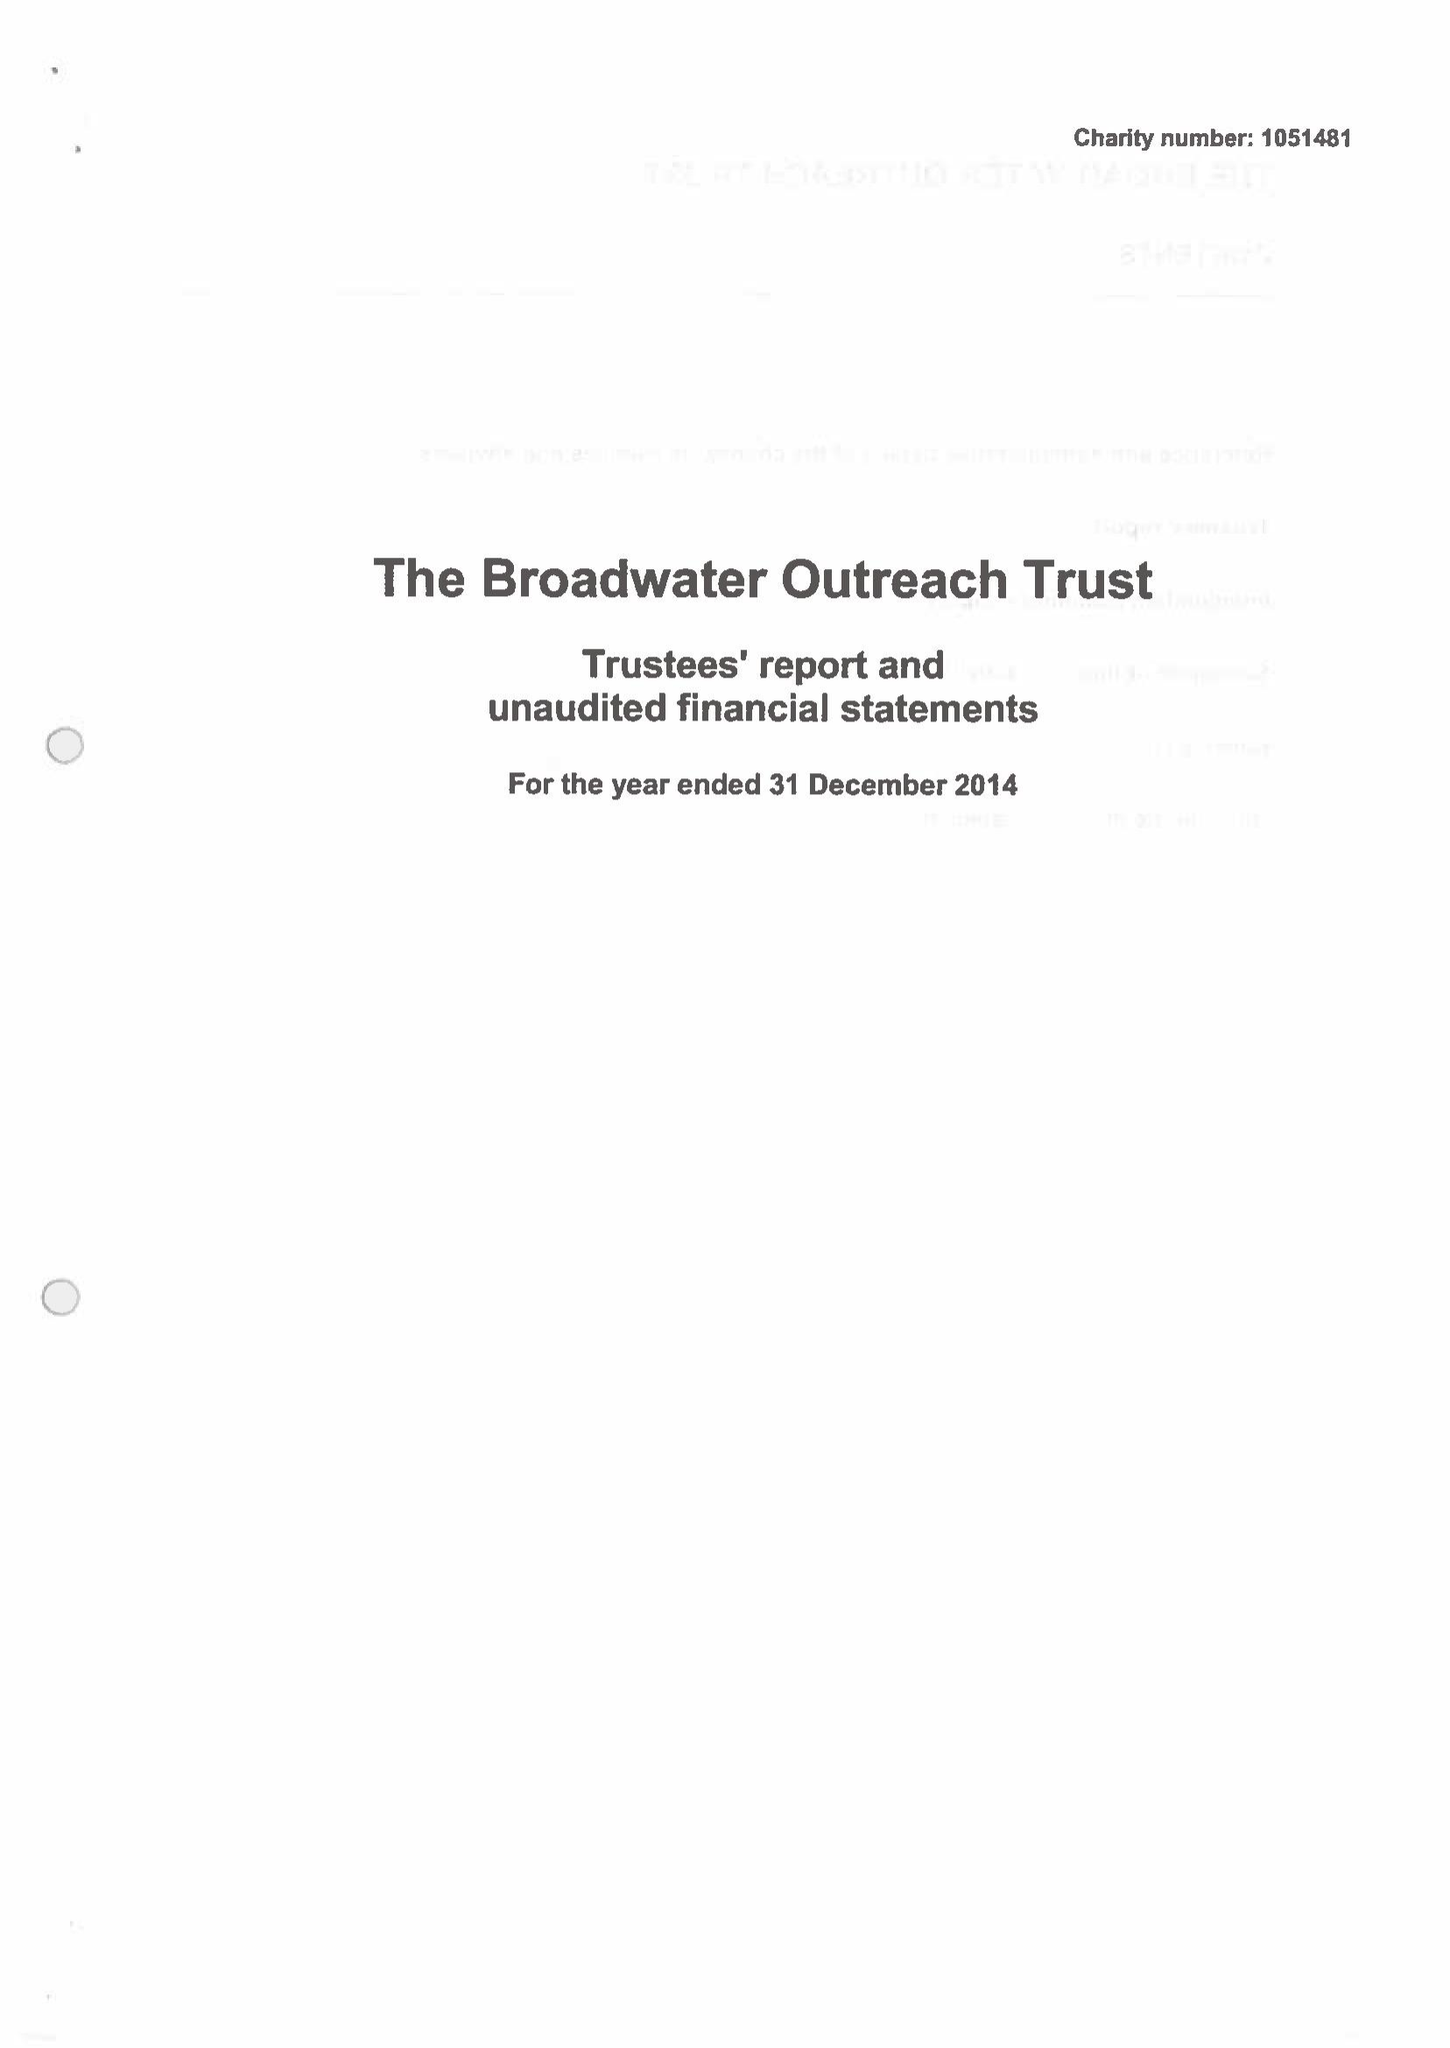What is the value for the spending_annually_in_british_pounds?
Answer the question using a single word or phrase. 26467.00 